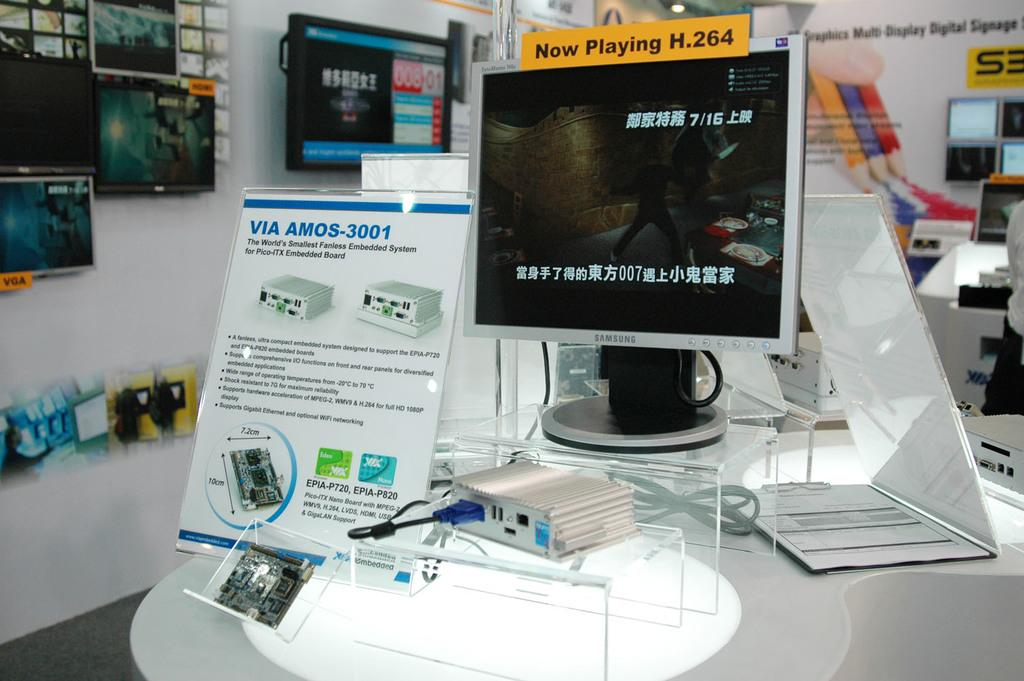Provide a one-sentence caption for the provided image. The sign says now playing H 264 on the screen. 